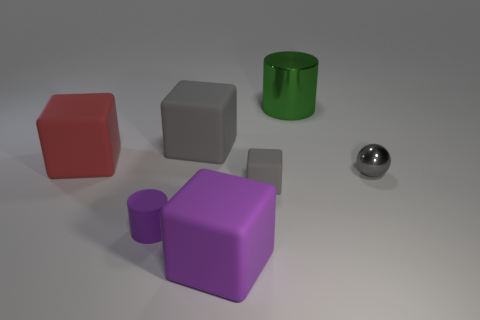Subtract all purple cubes. How many cubes are left? 3 Subtract all brown cubes. Subtract all purple spheres. How many cubes are left? 4 Add 3 tiny spheres. How many objects exist? 10 Subtract all cubes. How many objects are left? 3 Add 6 tiny metallic balls. How many tiny metallic balls are left? 7 Add 2 tiny brown metal balls. How many tiny brown metal balls exist? 2 Subtract 1 green cylinders. How many objects are left? 6 Subtract all big red objects. Subtract all red matte blocks. How many objects are left? 5 